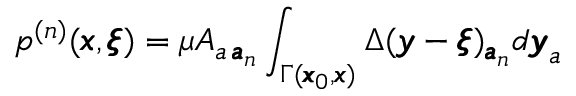<formula> <loc_0><loc_0><loc_500><loc_500>p ^ { ( n ) } ( { \pm b x } , { \pm b \xi } ) = \mu A _ { a \, { \pm b a } _ { n } } \int _ { \Gamma ( { \pm b x } _ { 0 } , { \pm b x } ) } \Delta ( { \pm b y } - { \pm b \xi } ) _ { { \pm b a } _ { n } } d { \pm b y } _ { a }</formula> 